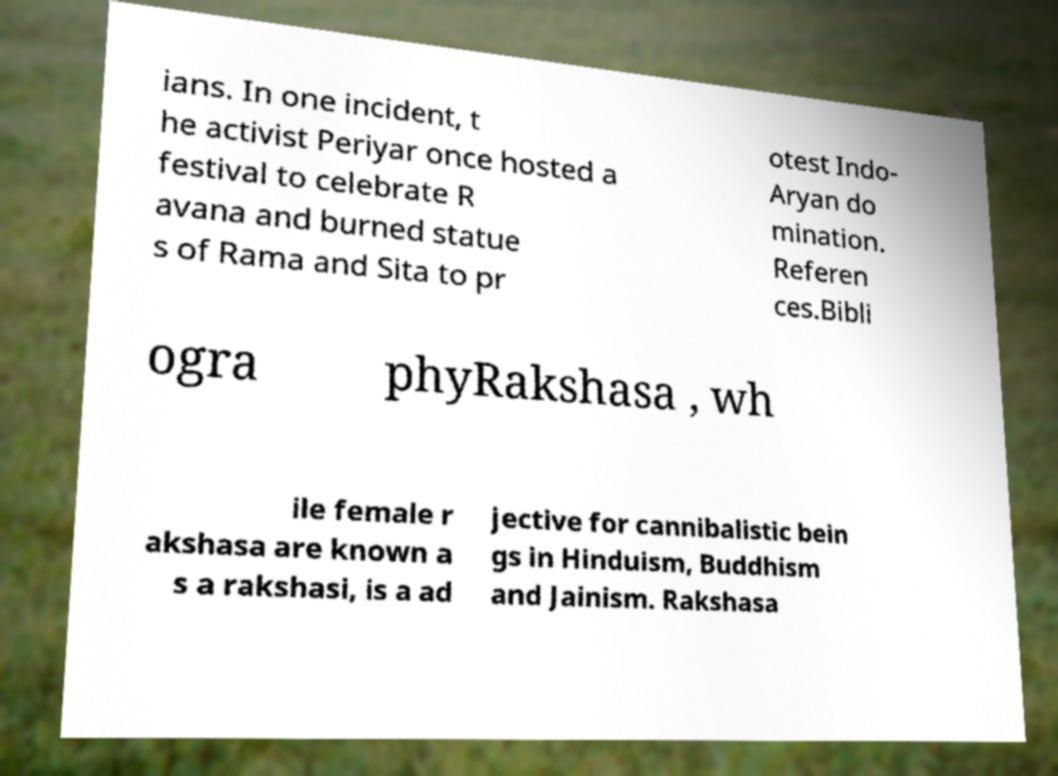I need the written content from this picture converted into text. Can you do that? ians. In one incident, t he activist Periyar once hosted a festival to celebrate R avana and burned statue s of Rama and Sita to pr otest Indo- Aryan do mination. Referen ces.Bibli ogra phyRakshasa , wh ile female r akshasa are known a s a rakshasi, is a ad jective for cannibalistic bein gs in Hinduism, Buddhism and Jainism. Rakshasa 